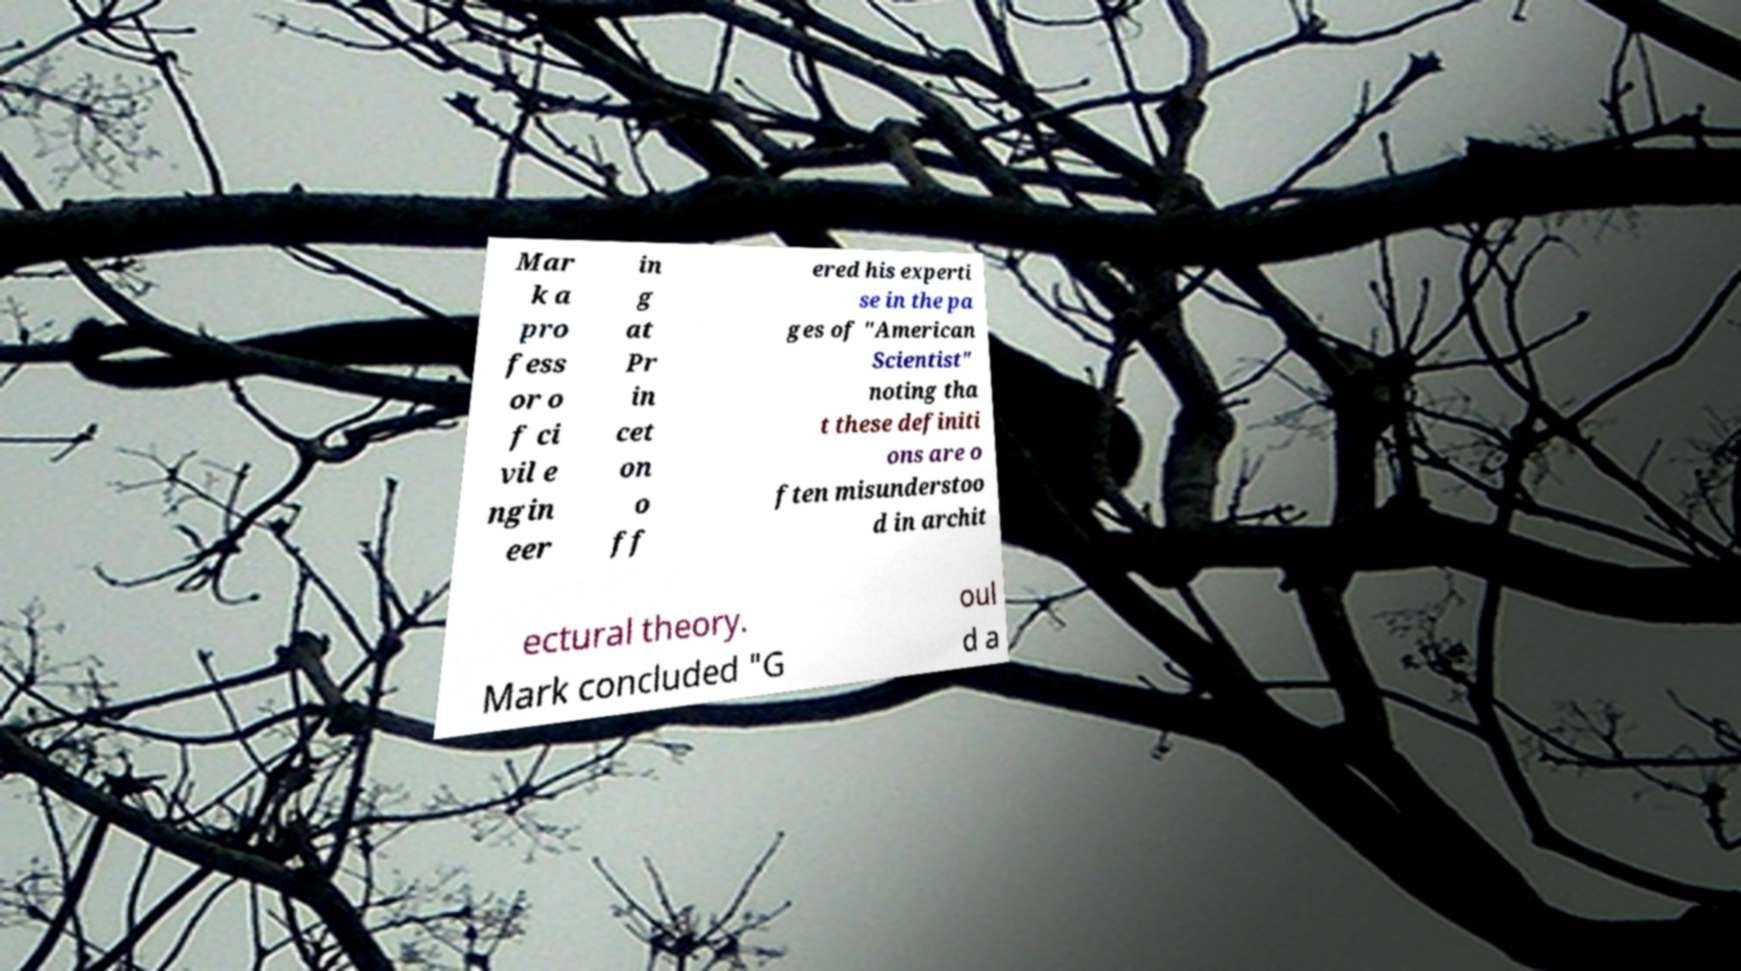There's text embedded in this image that I need extracted. Can you transcribe it verbatim? Mar k a pro fess or o f ci vil e ngin eer in g at Pr in cet on o ff ered his experti se in the pa ges of "American Scientist" noting tha t these definiti ons are o ften misunderstoo d in archit ectural theory. Mark concluded "G oul d a 